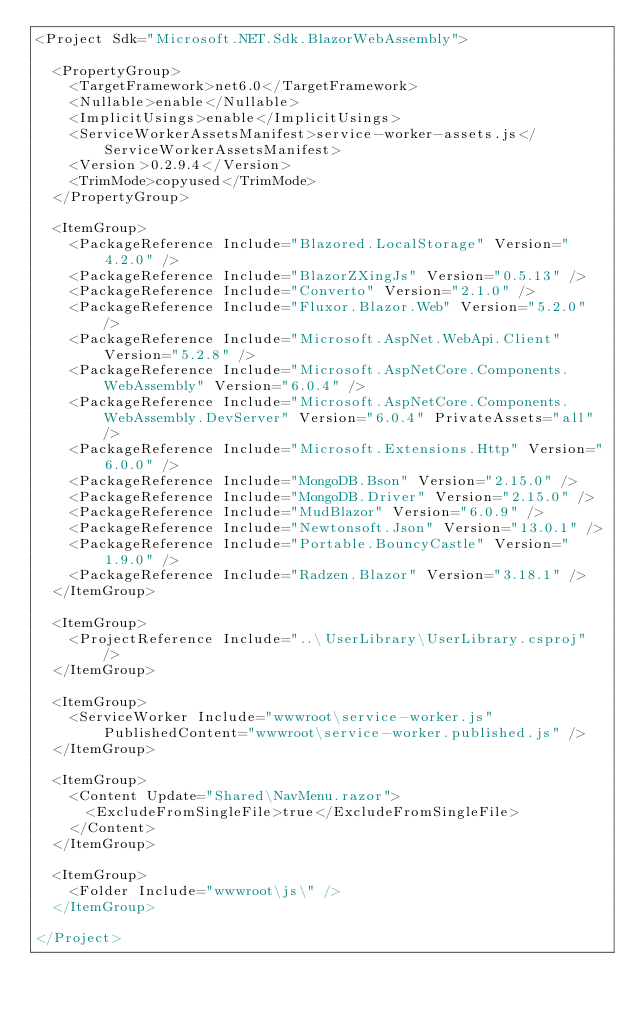<code> <loc_0><loc_0><loc_500><loc_500><_XML_><Project Sdk="Microsoft.NET.Sdk.BlazorWebAssembly">

  <PropertyGroup>
    <TargetFramework>net6.0</TargetFramework>
    <Nullable>enable</Nullable>
    <ImplicitUsings>enable</ImplicitUsings>
    <ServiceWorkerAssetsManifest>service-worker-assets.js</ServiceWorkerAssetsManifest>
    <Version>0.2.9.4</Version>
	<TrimMode>copyused</TrimMode>
  </PropertyGroup>

  <ItemGroup>
    <PackageReference Include="Blazored.LocalStorage" Version="4.2.0" />
    <PackageReference Include="BlazorZXingJs" Version="0.5.13" />
    <PackageReference Include="Converto" Version="2.1.0" />
    <PackageReference Include="Fluxor.Blazor.Web" Version="5.2.0" />
    <PackageReference Include="Microsoft.AspNet.WebApi.Client" Version="5.2.8" />
    <PackageReference Include="Microsoft.AspNetCore.Components.WebAssembly" Version="6.0.4" />
    <PackageReference Include="Microsoft.AspNetCore.Components.WebAssembly.DevServer" Version="6.0.4" PrivateAssets="all" />
    <PackageReference Include="Microsoft.Extensions.Http" Version="6.0.0" />
    <PackageReference Include="MongoDB.Bson" Version="2.15.0" />
    <PackageReference Include="MongoDB.Driver" Version="2.15.0" />
    <PackageReference Include="MudBlazor" Version="6.0.9" />
    <PackageReference Include="Newtonsoft.Json" Version="13.0.1" />
    <PackageReference Include="Portable.BouncyCastle" Version="1.9.0" />
    <PackageReference Include="Radzen.Blazor" Version="3.18.1" />
  </ItemGroup>

  <ItemGroup>
    <ProjectReference Include="..\UserLibrary\UserLibrary.csproj" />
  </ItemGroup>

  <ItemGroup>
    <ServiceWorker Include="wwwroot\service-worker.js" PublishedContent="wwwroot\service-worker.published.js" />
  </ItemGroup>

  <ItemGroup>
    <Content Update="Shared\NavMenu.razor">
      <ExcludeFromSingleFile>true</ExcludeFromSingleFile>
    </Content>
  </ItemGroup>

  <ItemGroup>
    <Folder Include="wwwroot\js\" />
  </ItemGroup>

</Project>
</code> 